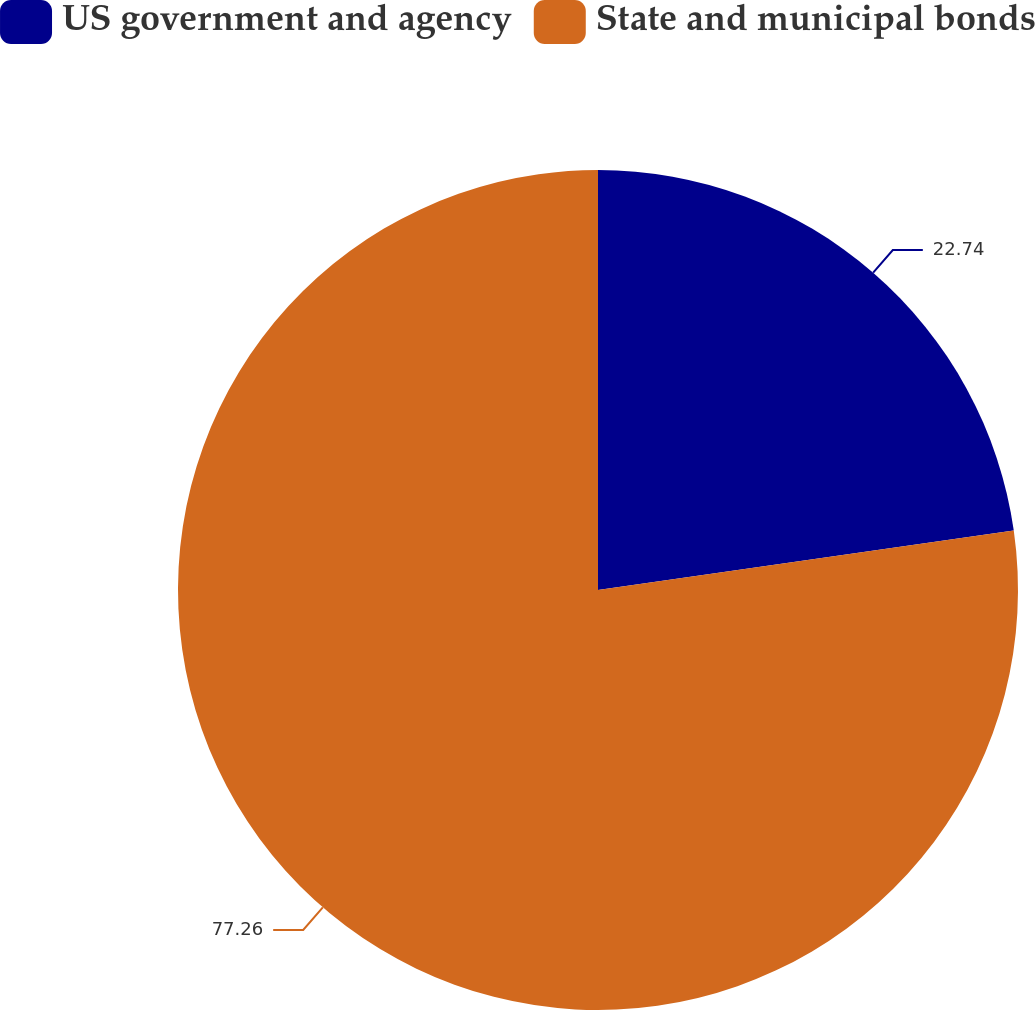<chart> <loc_0><loc_0><loc_500><loc_500><pie_chart><fcel>US government and agency<fcel>State and municipal bonds<nl><fcel>22.74%<fcel>77.26%<nl></chart> 